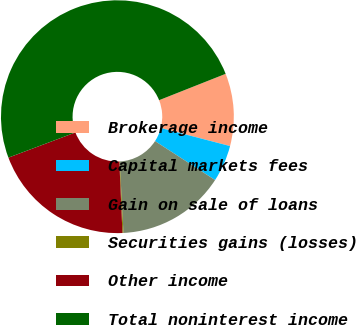Convert chart to OTSL. <chart><loc_0><loc_0><loc_500><loc_500><pie_chart><fcel>Brokerage income<fcel>Capital markets fees<fcel>Gain on sale of loans<fcel>Securities gains (losses)<fcel>Other income<fcel>Total noninterest income<nl><fcel>10.06%<fcel>5.1%<fcel>15.01%<fcel>0.14%<fcel>19.97%<fcel>49.71%<nl></chart> 